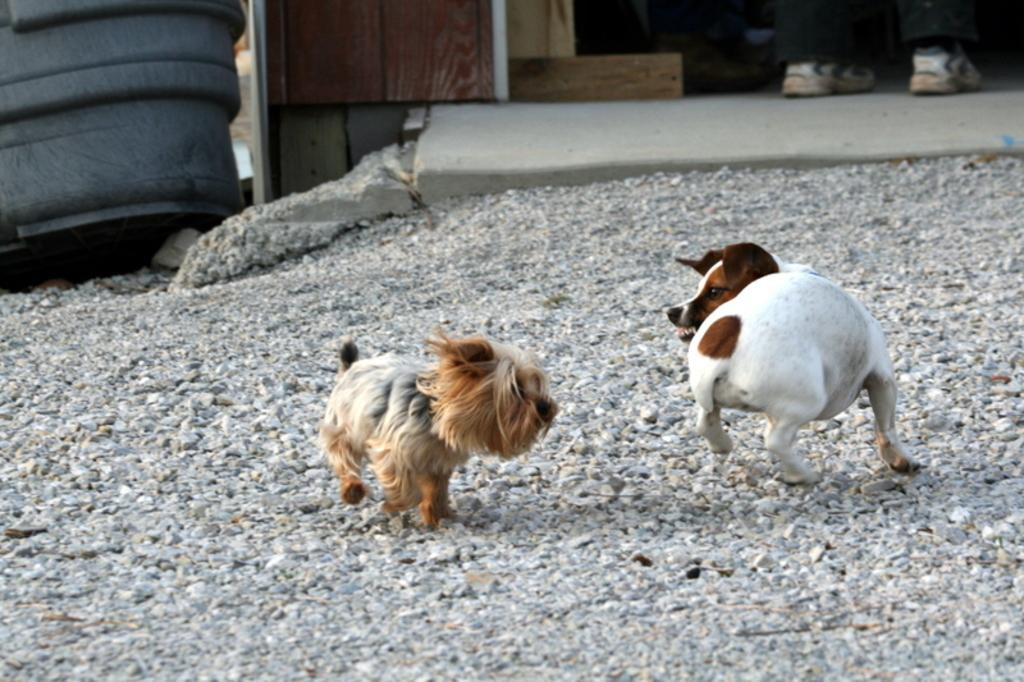What animals are running in the image? There are two dogs running in the image. What type of terrain can be seen in the image? There are stones visible in the image. What material is used for the objects at the top of the image? There are wooden pieces at the top of the image. What items might be used for walking or protection in the image? Footwear is present in the image. What type of fabric is visible in the image? Cloth is visible in the image. What other objects can be seen at the top of the image? There are other objects at the top of the image. What shape is the notebook in the image? There is no notebook present in the image. How many eggs are visible in the image? There are no eggs visible in the image. 